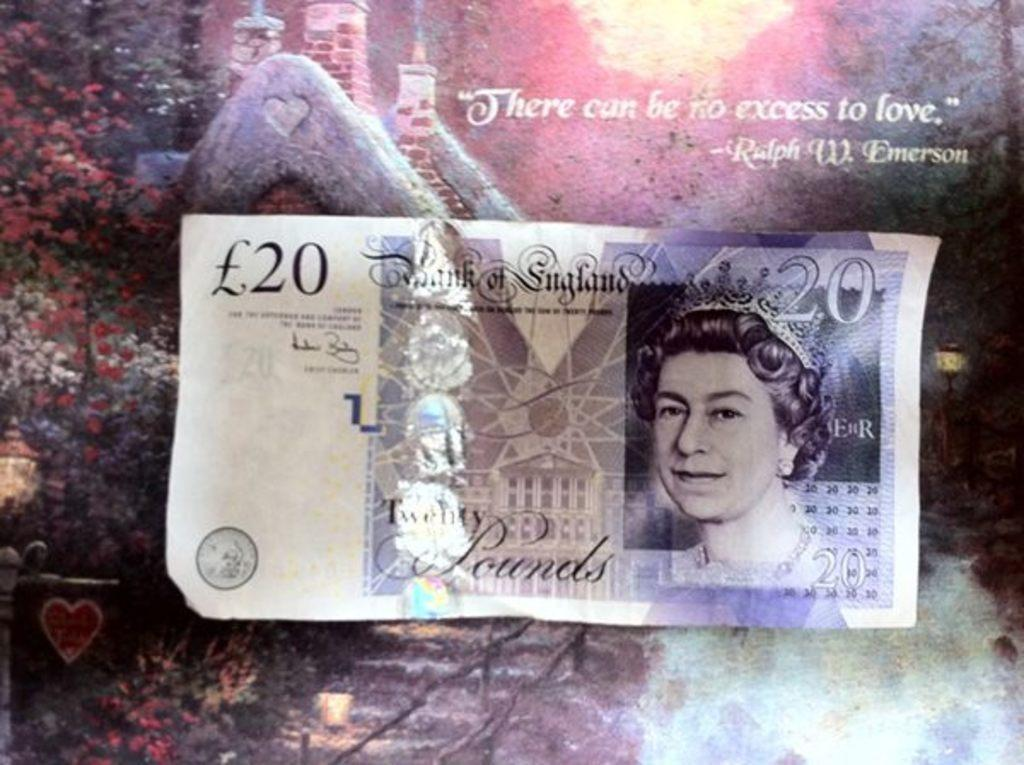What type of currency is visible in the image? There is a pound note in the image. What type of natural elements can be seen in the image? There are trees in the image. What type of man-made structures are visible in the image? There are buildings in the image. How would you describe the appearance of the background in the image? The background of the image has a multi-color appearance. Can you tell if the image has been altered or edited in any way? The image may have been edited, but it is not explicitly stated in the facts. How many bikes are parked near the trees in the image? There is no mention of bikes in the image, so it is not possible to answer this question. 